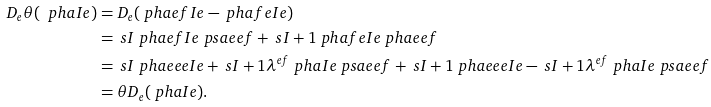Convert formula to latex. <formula><loc_0><loc_0><loc_500><loc_500>D _ { e } \theta ( \ p h a I e ) & = D _ { e } ( \ p h a { e f I } e - \ p h a { f e I } e ) \\ & = \ s { I } \ p h a { e f I } e \ p s a { e e } f + \ s { I + 1 } \ p h a { f e I } e \ p h a { e e } f \\ & = \ s { I } \ p h a { e e e I } e + \ s { I + 1 } \lambda ^ { e f } \ p h a I e \ p s a { e e } f + \ s { I + 1 } \ p h a { e e e I } e - \ s { I + 1 } \lambda ^ { e f } \ p h a I e \ p s a { e e } f \\ & = \theta D _ { e } ( \ p h a I e ) .</formula> 